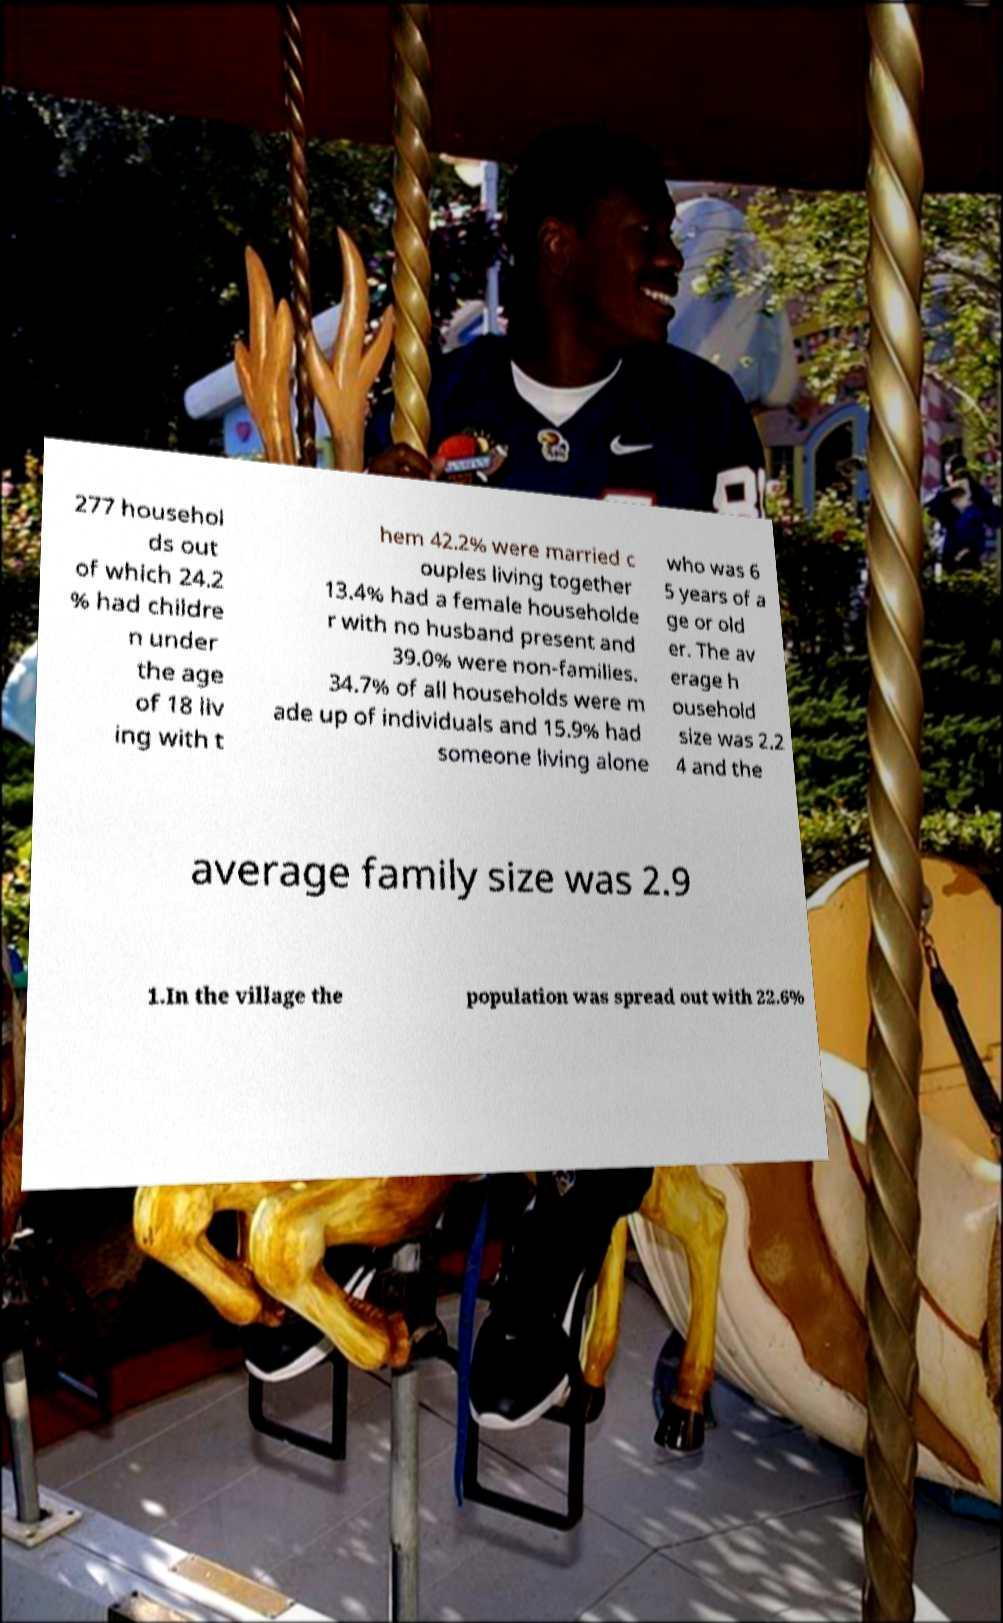Please read and relay the text visible in this image. What does it say? 277 househol ds out of which 24.2 % had childre n under the age of 18 liv ing with t hem 42.2% were married c ouples living together 13.4% had a female householde r with no husband present and 39.0% were non-families. 34.7% of all households were m ade up of individuals and 15.9% had someone living alone who was 6 5 years of a ge or old er. The av erage h ousehold size was 2.2 4 and the average family size was 2.9 1.In the village the population was spread out with 22.6% 